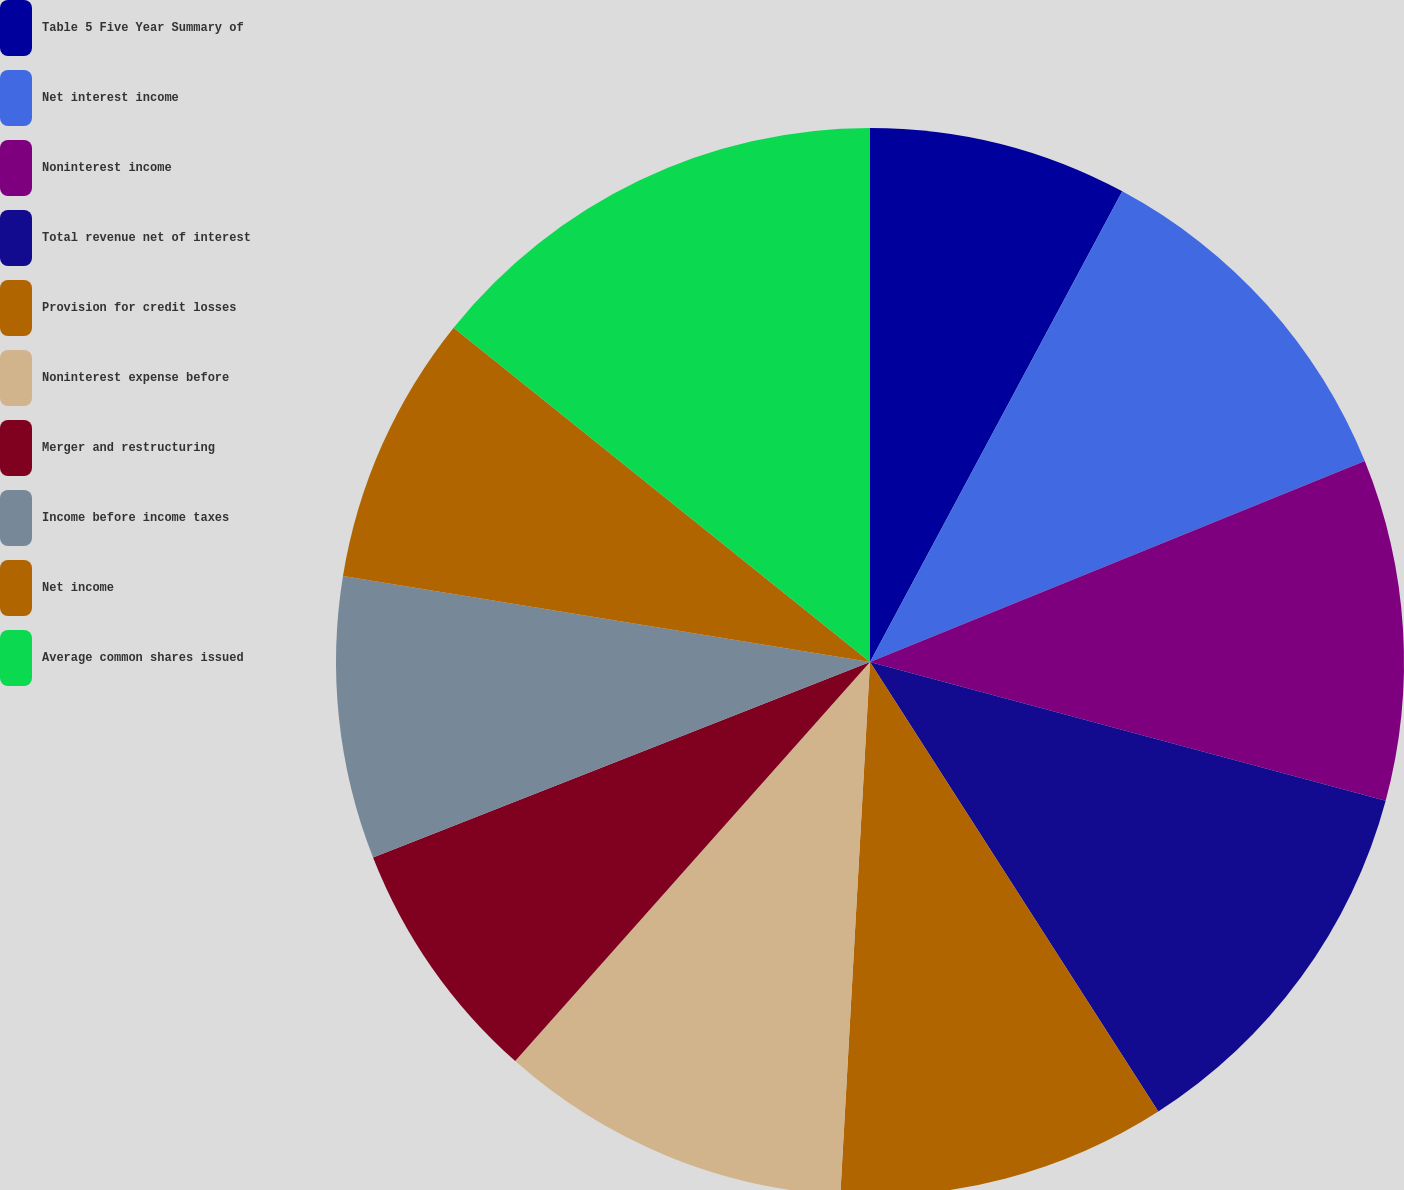Convert chart. <chart><loc_0><loc_0><loc_500><loc_500><pie_chart><fcel>Table 5 Five Year Summary of<fcel>Net interest income<fcel>Noninterest income<fcel>Total revenue net of interest<fcel>Provision for credit losses<fcel>Noninterest expense before<fcel>Merger and restructuring<fcel>Income before income taxes<fcel>Net income<fcel>Average common shares issued<nl><fcel>7.83%<fcel>11.03%<fcel>10.32%<fcel>11.74%<fcel>9.96%<fcel>10.68%<fcel>7.47%<fcel>8.54%<fcel>8.19%<fcel>14.23%<nl></chart> 